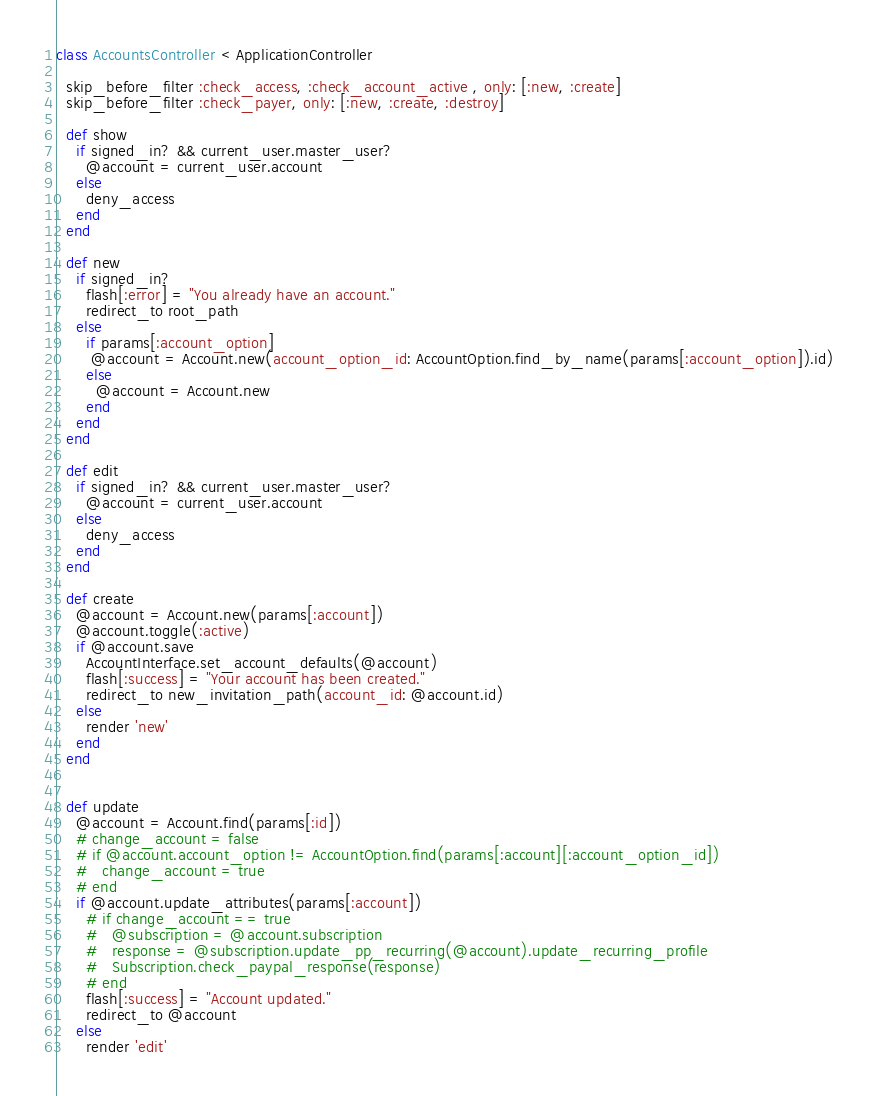<code> <loc_0><loc_0><loc_500><loc_500><_Ruby_>class AccountsController < ApplicationController

  skip_before_filter :check_access, :check_account_active , only: [:new, :create]
  skip_before_filter :check_payer, only: [:new, :create, :destroy]

  def show
    if signed_in? && current_user.master_user?
      @account = current_user.account
    else
      deny_access
    end
  end

  def new
    if signed_in?
      flash[:error] = "You already have an account."
      redirect_to root_path
    else
      if params[:account_option]
       @account = Account.new(account_option_id: AccountOption.find_by_name(params[:account_option]).id)
      else
        @account = Account.new
      end
    end
  end

  def edit
    if signed_in? && current_user.master_user?
      @account = current_user.account
    else
      deny_access
    end
  end

  def create
    @account = Account.new(params[:account])
    @account.toggle(:active)
    if @account.save
      AccountInterface.set_account_defaults(@account)
      flash[:success] = "Your account has been created."
      redirect_to new_invitation_path(account_id: @account.id)
    else
      render 'new'
    end
  end


  def update
    @account = Account.find(params[:id])
    # change_account = false
    # if @account.account_option != AccountOption.find(params[:account][:account_option_id])
    #   change_account = true
    # end
    if @account.update_attributes(params[:account])
      # if change_account == true
      #   @subscription = @account.subscription
      #   response = @subscription.update_pp_recurring(@account).update_recurring_profile
      #   Subscription.check_paypal_response(response)
      # end
      flash[:success] = "Account updated."
      redirect_to @account
    else
      render 'edit'</code> 